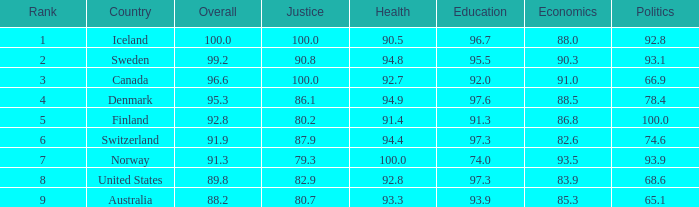What's the economics score with justice being 90.8 90.3. 